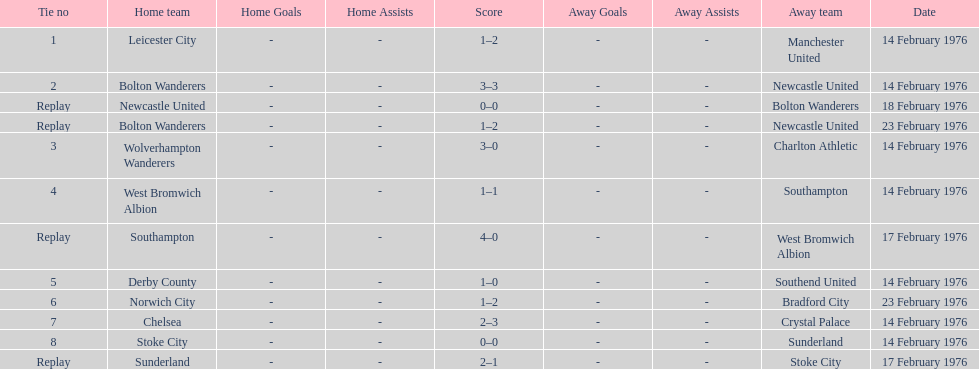How many games did the bolton wanderers and newcastle united play before there was a definitive winner in the fifth round proper? 3. Could you parse the entire table as a dict? {'header': ['Tie no', 'Home team', 'Home Goals', 'Home Assists', 'Score', 'Away Goals', 'Away Assists', 'Away team', 'Date'], 'rows': [['1', 'Leicester City', '-', '-', '1–2', '-', '-', 'Manchester United', '14 February 1976'], ['2', 'Bolton Wanderers', '-', '-', '3–3', '-', '-', 'Newcastle United', '14 February 1976'], ['Replay', 'Newcastle United', '-', '-', '0–0', '-', '-', 'Bolton Wanderers', '18 February 1976'], ['Replay', 'Bolton Wanderers', '-', '-', '1–2', '-', '-', 'Newcastle United', '23 February 1976'], ['3', 'Wolverhampton Wanderers', '-', '-', '3–0', '-', '-', 'Charlton Athletic', '14 February 1976'], ['4', 'West Bromwich Albion', '-', '-', '1–1', '-', '-', 'Southampton', '14 February 1976'], ['Replay', 'Southampton', '-', '-', '4–0', '-', '-', 'West Bromwich Albion', '17 February 1976'], ['5', 'Derby County', '-', '-', '1–0', '-', '-', 'Southend United', '14 February 1976'], ['6', 'Norwich City', '-', '-', '1–2', '-', '-', 'Bradford City', '23 February 1976'], ['7', 'Chelsea', '-', '-', '2–3', '-', '-', 'Crystal Palace', '14 February 1976'], ['8', 'Stoke City', '-', '-', '0–0', '-', '-', 'Sunderland', '14 February 1976'], ['Replay', 'Sunderland', '-', '-', '2–1', '-', '-', 'Stoke City', '17 February 1976']]} 